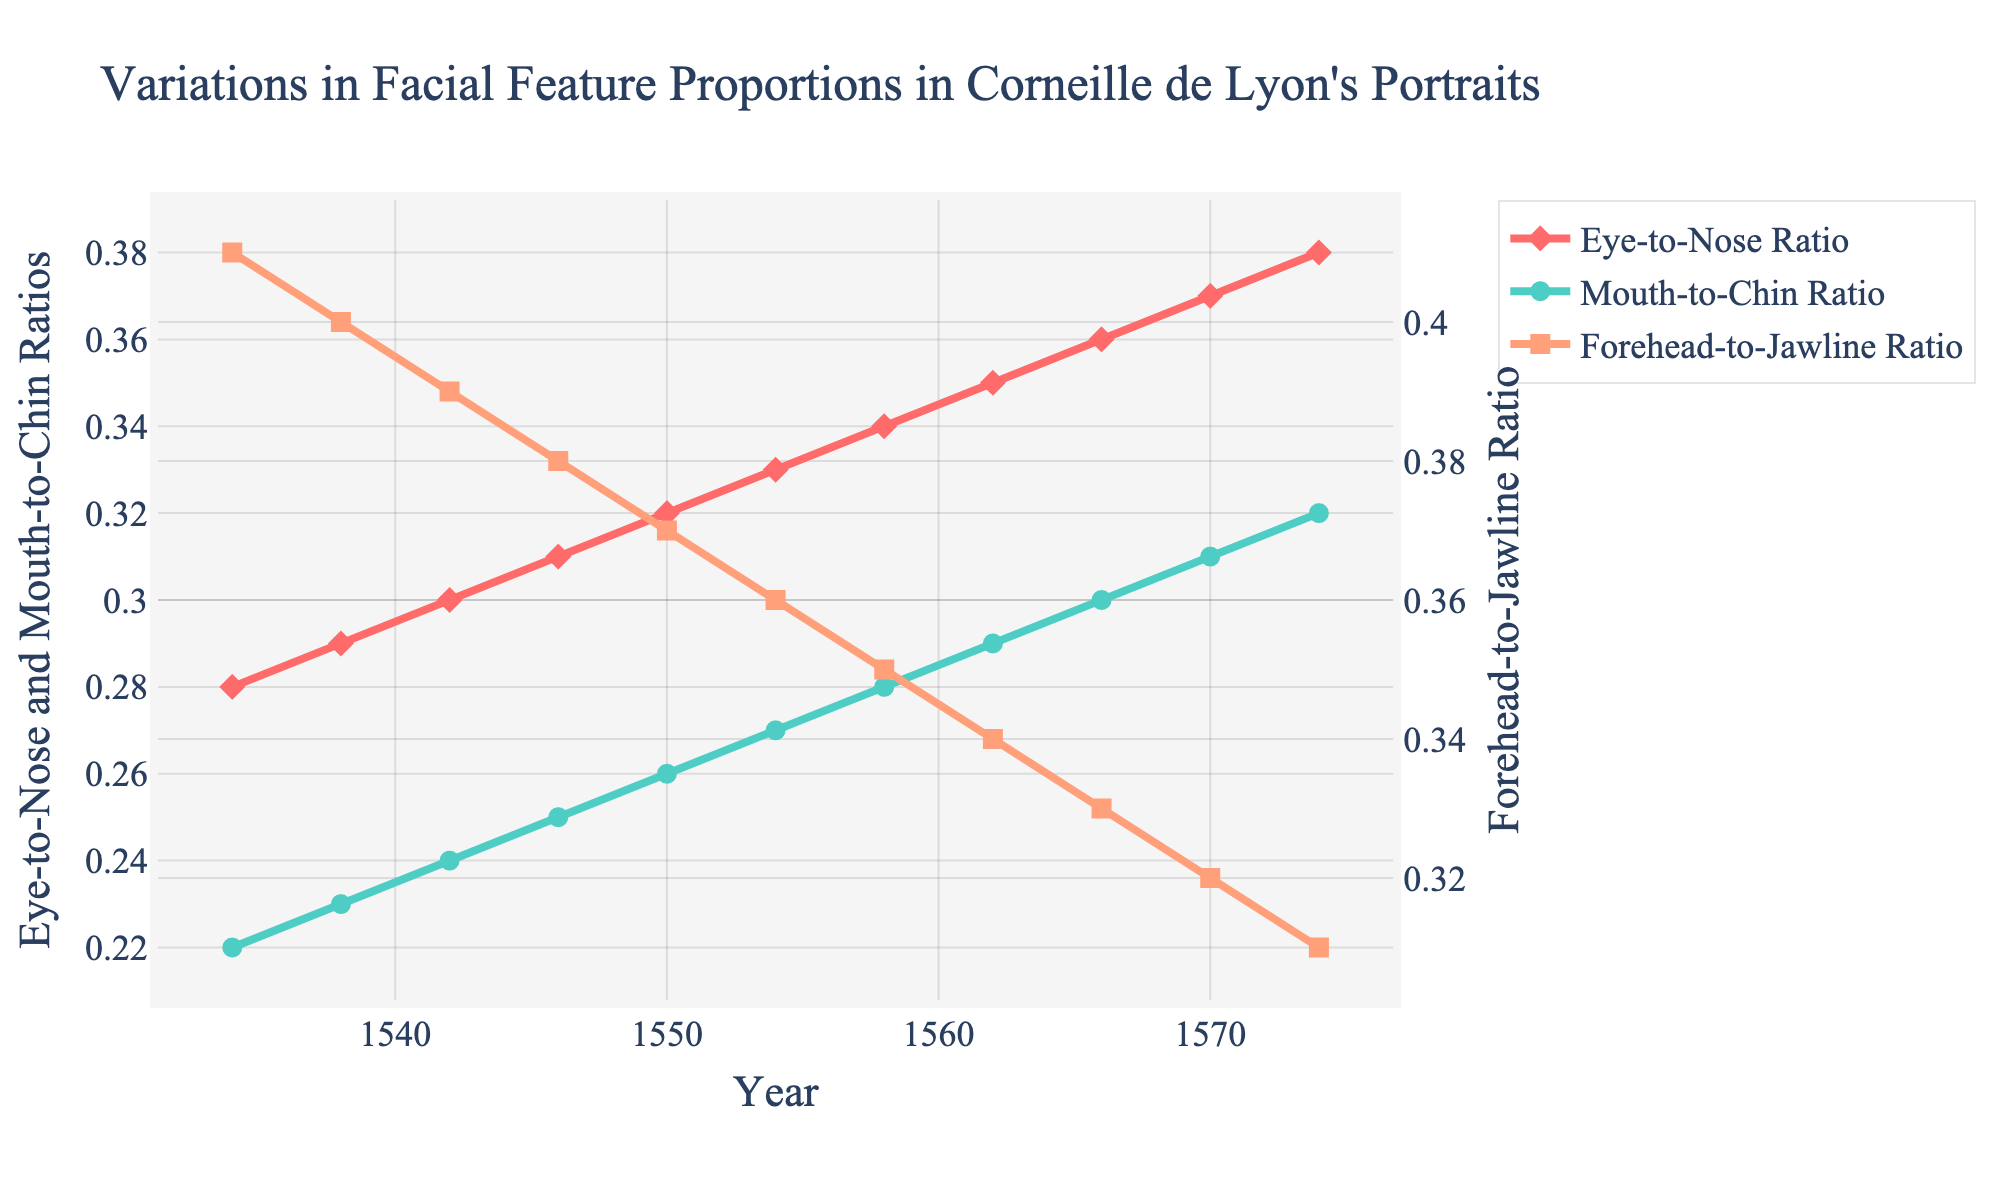What trend do you observe in the Eye-to-Nose Ratio over the decades? The Eye-to-Nose Ratio increases steadily from 0.28 in 1534 to 0.38 in 1574. On the figure, the red line representing the Eye-to-Nose Ratio shows a consistent upward trend.
Answer: It increases How does the Mouth-to-Chin Ratio in 1554 compare to the ratio in 1542? The Mouth-to-Chin Ratio in 1542 is 0.24. In 1554, it is 0.27. Comparing these values, we see the ratio increased by 0.03. Visually, the green line representing the Mouth-to-Chin Ratio rises between these years.
Answer: 0.03 higher What is the difference between the maximum Forehead-to-Jawline Ratio and the minimum Forehead-to-Jawline Ratio? The maximum Forehead-to-Jawline Ratio is 0.41 in 1534, and the minimum is 0.31 in 1574. The difference is calculated as 0.41 - 0.31 = 0.10. This is shown by the orange line decreasing over the decades.
Answer: 0.10 Which year shows the highest value for the Eye-to-Nose Ratio? By examining the figure, the year with the highest Eye-to-Nose Ratio is 1574, where the red line reaches its peak.
Answer: 1574 What is the average Mouth-to-Chin Ratio for the years 1550, 1554, and 1558? The Mouth-to-Chin Ratios for the years 1550, 1554, and 1558 are 0.26, 0.27, and 0.28 respectively. The sum is 0.26 + 0.27 + 0.28 = 0.81. Dividing by 3 gives an average of 0.81/3 = 0.27.
Answer: 0.27 In which year did the Forehead-to-Jawline Ratio first drop below 0.35? The orange line representing the Forehead-to-Jawline Ratio first drops below 0.35 in the year 1558.
Answer: 1558 How did the Eye-to-Nose Ratio and Mouth-to-Chin Ratio change between 1534 and 1574? The Eye-to-Nose Ratio increased from 0.28 to 0.38. The Mouth-to-Chin Ratio increased from 0.22 to 0.32. Both ratios exhibit an increasing trend over this period. This is seen by the upward paths of the red and green lines.
Answer: Both increased Compare the trend of the Forehead-to-Jawline Ratio with the Eye-to-Nose Ratio between 1546 and 1570. Between 1546 and 1570, the Forehead-to-Jawline Ratio shows a decreasing trend, moving from 0.38 to 0.32. Conversely, the Eye-to-Nose Ratio increases from 0.31 to 0.37 during the same period. The orange line descends while the red line ascends.
Answer: Forehead-to-Jawline decreases, Eye-to-Nose increases What is the combined total increase in the Eye-to-Nose Ratio from 1534 to 1574? The Eye-to-Nose Ratio increased from 0.28 in 1534 to 0.38 in 1574. The combined total increase is 0.38 - 0.28 = 0.10.
Answer: 0.10 Between the years 1542 and 1566, identify the year that observed the greatest change in the Mouth-to-Chin Ratio. The Mouth-to-Chin Ratio changes year-by-year from 1542 (0.24), 1546 (0.25), 1550 (0.26), 1554 (0.27), 1558 (0.28), 1562 (0.29), and 1566 (0.30). The greatest change within this range is in any single year, which is uniformly 0.01 each year as seen by the consistent step increases in the green line.
Answer: Each year changes uniformly by 0.01 